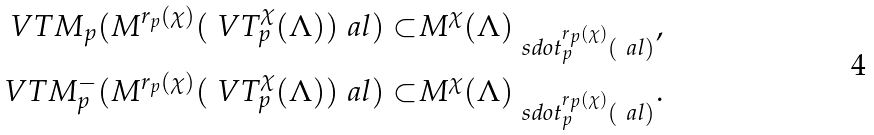<formula> <loc_0><loc_0><loc_500><loc_500>\ V T M _ { p } ( M ^ { r _ { p } ( \chi ) } ( \ V T ^ { \chi } _ { p } ( \Lambda ) ) _ { \ } a l ) \subset & M ^ { \chi } ( \Lambda ) _ { \ s d o t _ { p } ^ { r _ { p } ( \chi ) } ( \ a l ) } , \\ \ V T M ^ { - } _ { p } ( M ^ { r _ { p } ( \chi ) } ( \ V T ^ { \chi } _ { p } ( \Lambda ) ) _ { \ } a l ) \subset & M ^ { \chi } ( \Lambda ) _ { \ s d o t _ { p } ^ { r _ { p } ( \chi ) } ( \ a l ) } .</formula> 